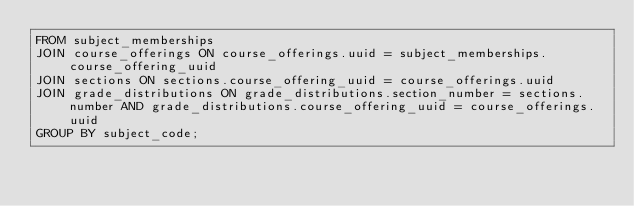<code> <loc_0><loc_0><loc_500><loc_500><_SQL_>FROM subject_memberships
JOIN course_offerings ON course_offerings.uuid = subject_memberships.course_offering_uuid
JOIN sections ON sections.course_offering_uuid = course_offerings.uuid
JOIN grade_distributions ON grade_distributions.section_number = sections.number AND grade_distributions.course_offering_uuid = course_offerings.uuid
GROUP BY subject_code;</code> 